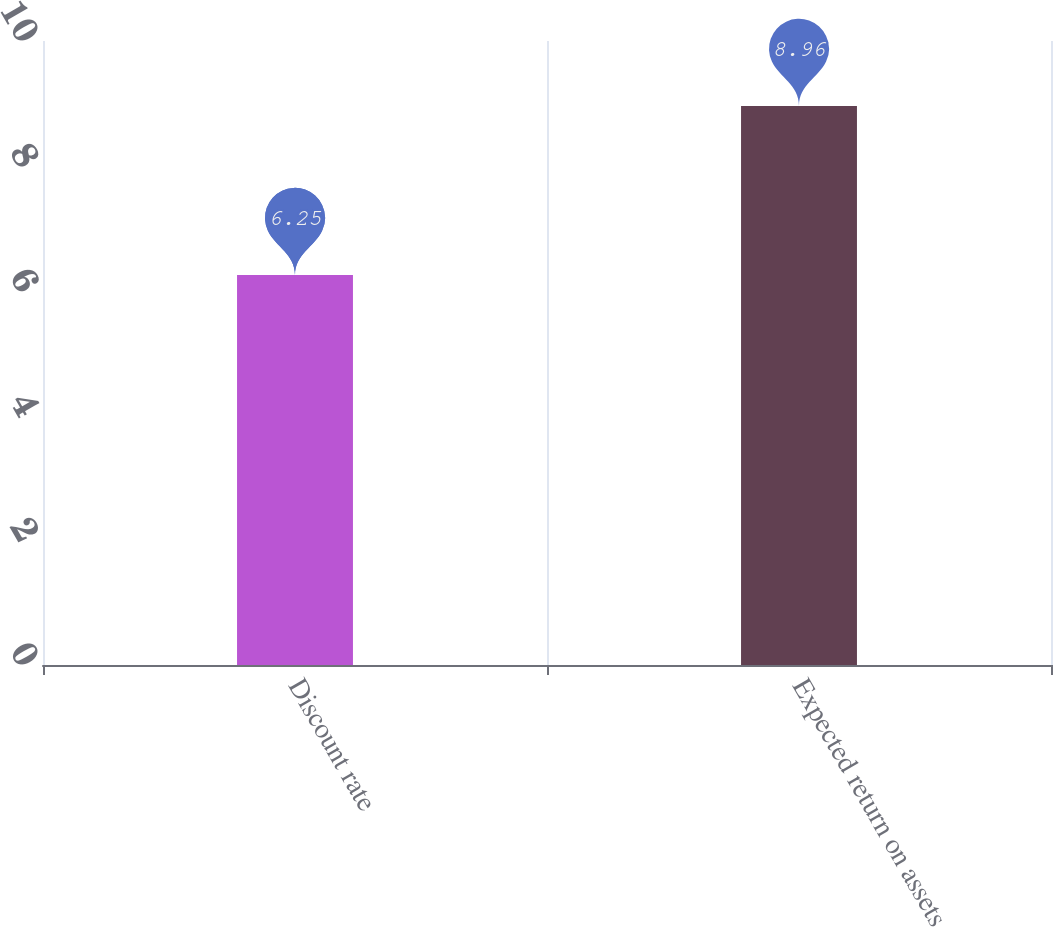Convert chart to OTSL. <chart><loc_0><loc_0><loc_500><loc_500><bar_chart><fcel>Discount rate<fcel>Expected return on assets<nl><fcel>6.25<fcel>8.96<nl></chart> 